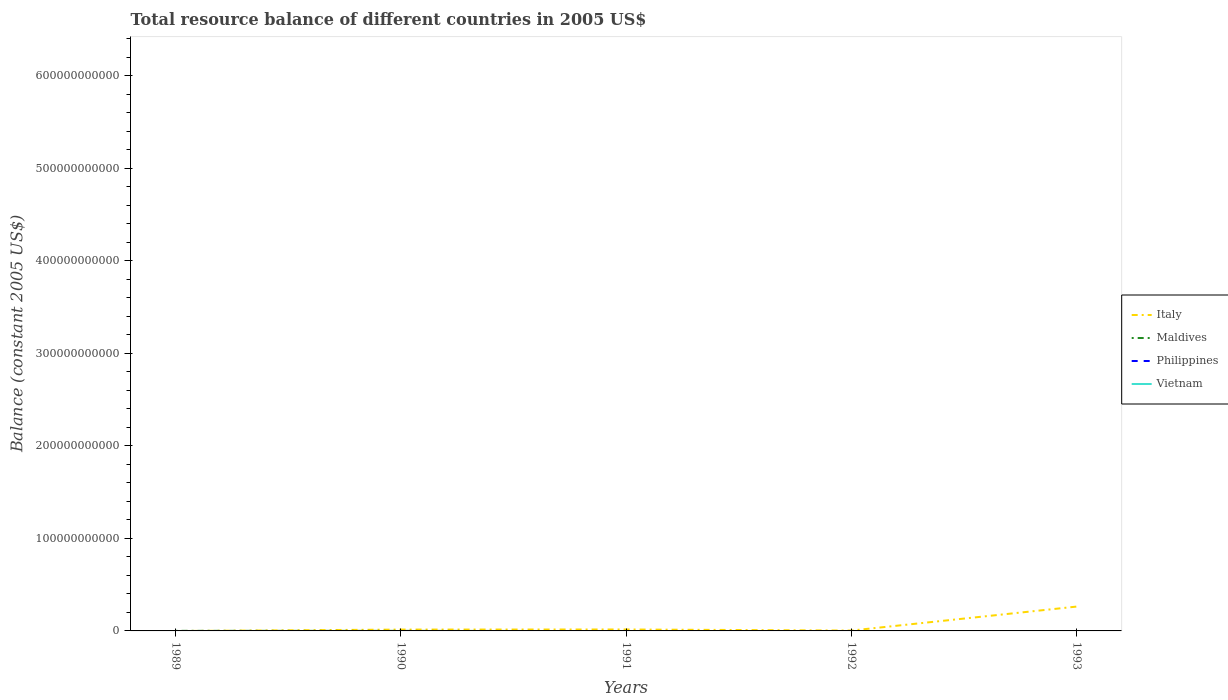Does the line corresponding to Maldives intersect with the line corresponding to Italy?
Your answer should be compact. Yes. Is the number of lines equal to the number of legend labels?
Keep it short and to the point. No. What is the total total resource balance in Italy in the graph?
Provide a succinct answer. -2.59e+1. What is the difference between the highest and the second highest total resource balance in Maldives?
Give a very brief answer. 8.95e+07. What is the difference between the highest and the lowest total resource balance in Philippines?
Keep it short and to the point. 0. Is the total resource balance in Vietnam strictly greater than the total resource balance in Italy over the years?
Provide a short and direct response. Yes. How many lines are there?
Ensure brevity in your answer.  2. How many years are there in the graph?
Provide a short and direct response. 5. What is the difference between two consecutive major ticks on the Y-axis?
Your response must be concise. 1.00e+11. Does the graph contain any zero values?
Provide a short and direct response. Yes. Does the graph contain grids?
Ensure brevity in your answer.  No. Where does the legend appear in the graph?
Provide a succinct answer. Center right. How are the legend labels stacked?
Offer a very short reply. Vertical. What is the title of the graph?
Provide a short and direct response. Total resource balance of different countries in 2005 US$. Does "Egypt, Arab Rep." appear as one of the legend labels in the graph?
Give a very brief answer. No. What is the label or title of the X-axis?
Offer a very short reply. Years. What is the label or title of the Y-axis?
Provide a succinct answer. Balance (constant 2005 US$). What is the Balance (constant 2005 US$) in Italy in 1989?
Offer a terse response. 0. What is the Balance (constant 2005 US$) in Maldives in 1989?
Your answer should be compact. 8.95e+07. What is the Balance (constant 2005 US$) of Vietnam in 1989?
Your answer should be compact. 0. What is the Balance (constant 2005 US$) in Italy in 1990?
Give a very brief answer. 1.45e+09. What is the Balance (constant 2005 US$) in Maldives in 1990?
Give a very brief answer. 5.81e+07. What is the Balance (constant 2005 US$) of Italy in 1991?
Offer a terse response. 1.56e+09. What is the Balance (constant 2005 US$) in Maldives in 1991?
Offer a terse response. 0. What is the Balance (constant 2005 US$) of Philippines in 1991?
Provide a succinct answer. 0. What is the Balance (constant 2005 US$) of Vietnam in 1991?
Keep it short and to the point. 0. What is the Balance (constant 2005 US$) of Italy in 1992?
Make the answer very short. 3.90e+08. What is the Balance (constant 2005 US$) of Maldives in 1992?
Make the answer very short. 0. What is the Balance (constant 2005 US$) in Vietnam in 1992?
Give a very brief answer. 0. What is the Balance (constant 2005 US$) of Italy in 1993?
Your response must be concise. 2.63e+1. What is the Balance (constant 2005 US$) in Maldives in 1993?
Your answer should be very brief. 0. What is the Balance (constant 2005 US$) of Philippines in 1993?
Offer a very short reply. 0. Across all years, what is the maximum Balance (constant 2005 US$) of Italy?
Your answer should be compact. 2.63e+1. Across all years, what is the maximum Balance (constant 2005 US$) of Maldives?
Offer a terse response. 8.95e+07. Across all years, what is the minimum Balance (constant 2005 US$) of Italy?
Your answer should be compact. 0. What is the total Balance (constant 2005 US$) in Italy in the graph?
Offer a terse response. 2.97e+1. What is the total Balance (constant 2005 US$) in Maldives in the graph?
Your answer should be compact. 1.48e+08. What is the total Balance (constant 2005 US$) of Vietnam in the graph?
Keep it short and to the point. 0. What is the difference between the Balance (constant 2005 US$) of Maldives in 1989 and that in 1990?
Offer a terse response. 3.14e+07. What is the difference between the Balance (constant 2005 US$) in Italy in 1990 and that in 1991?
Offer a terse response. -1.05e+08. What is the difference between the Balance (constant 2005 US$) in Italy in 1990 and that in 1992?
Give a very brief answer. 1.06e+09. What is the difference between the Balance (constant 2005 US$) in Italy in 1990 and that in 1993?
Keep it short and to the point. -2.49e+1. What is the difference between the Balance (constant 2005 US$) in Italy in 1991 and that in 1992?
Keep it short and to the point. 1.17e+09. What is the difference between the Balance (constant 2005 US$) of Italy in 1991 and that in 1993?
Your answer should be compact. -2.48e+1. What is the difference between the Balance (constant 2005 US$) of Italy in 1992 and that in 1993?
Provide a short and direct response. -2.59e+1. What is the average Balance (constant 2005 US$) in Italy per year?
Offer a terse response. 5.94e+09. What is the average Balance (constant 2005 US$) of Maldives per year?
Provide a short and direct response. 2.95e+07. What is the average Balance (constant 2005 US$) of Philippines per year?
Keep it short and to the point. 0. What is the average Balance (constant 2005 US$) of Vietnam per year?
Make the answer very short. 0. In the year 1990, what is the difference between the Balance (constant 2005 US$) in Italy and Balance (constant 2005 US$) in Maldives?
Provide a short and direct response. 1.40e+09. What is the ratio of the Balance (constant 2005 US$) of Maldives in 1989 to that in 1990?
Give a very brief answer. 1.54. What is the ratio of the Balance (constant 2005 US$) of Italy in 1990 to that in 1991?
Keep it short and to the point. 0.93. What is the ratio of the Balance (constant 2005 US$) in Italy in 1990 to that in 1992?
Make the answer very short. 3.73. What is the ratio of the Balance (constant 2005 US$) of Italy in 1990 to that in 1993?
Provide a short and direct response. 0.06. What is the ratio of the Balance (constant 2005 US$) of Italy in 1991 to that in 1992?
Provide a succinct answer. 4. What is the ratio of the Balance (constant 2005 US$) of Italy in 1991 to that in 1993?
Give a very brief answer. 0.06. What is the ratio of the Balance (constant 2005 US$) in Italy in 1992 to that in 1993?
Provide a short and direct response. 0.01. What is the difference between the highest and the second highest Balance (constant 2005 US$) in Italy?
Provide a succinct answer. 2.48e+1. What is the difference between the highest and the lowest Balance (constant 2005 US$) in Italy?
Provide a short and direct response. 2.63e+1. What is the difference between the highest and the lowest Balance (constant 2005 US$) in Maldives?
Make the answer very short. 8.95e+07. 